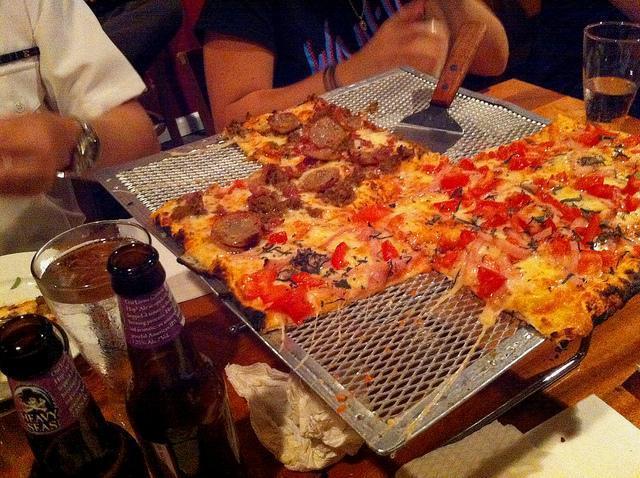How many people are in the photo?
Give a very brief answer. 2. How many bottles can you see?
Give a very brief answer. 2. How many dining tables are in the photo?
Give a very brief answer. 2. How many cups are in the photo?
Give a very brief answer. 2. How many pizzas can be seen?
Give a very brief answer. 2. How many baby elephants are there?
Give a very brief answer. 0. 